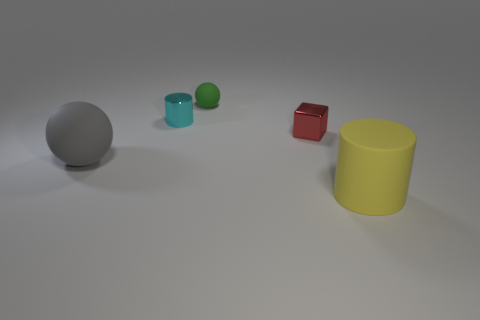Can you describe the scene depicted in this image and the objects present? Certainly, the image showcases a simple scene with a variety of geometric shapes scattered across a plain surface. On the far left, there's a large grey sphere. Moving rightwards, we come across a smaller green sphere, followed by an even tinier cyan colored cube. Finally, situated on the extreme right, there is a sizeable yellow cylinder. The objects exhibit a matte texture and are lit with a soft, diffused light suggesting an indoor setting with a possibly single light source. 